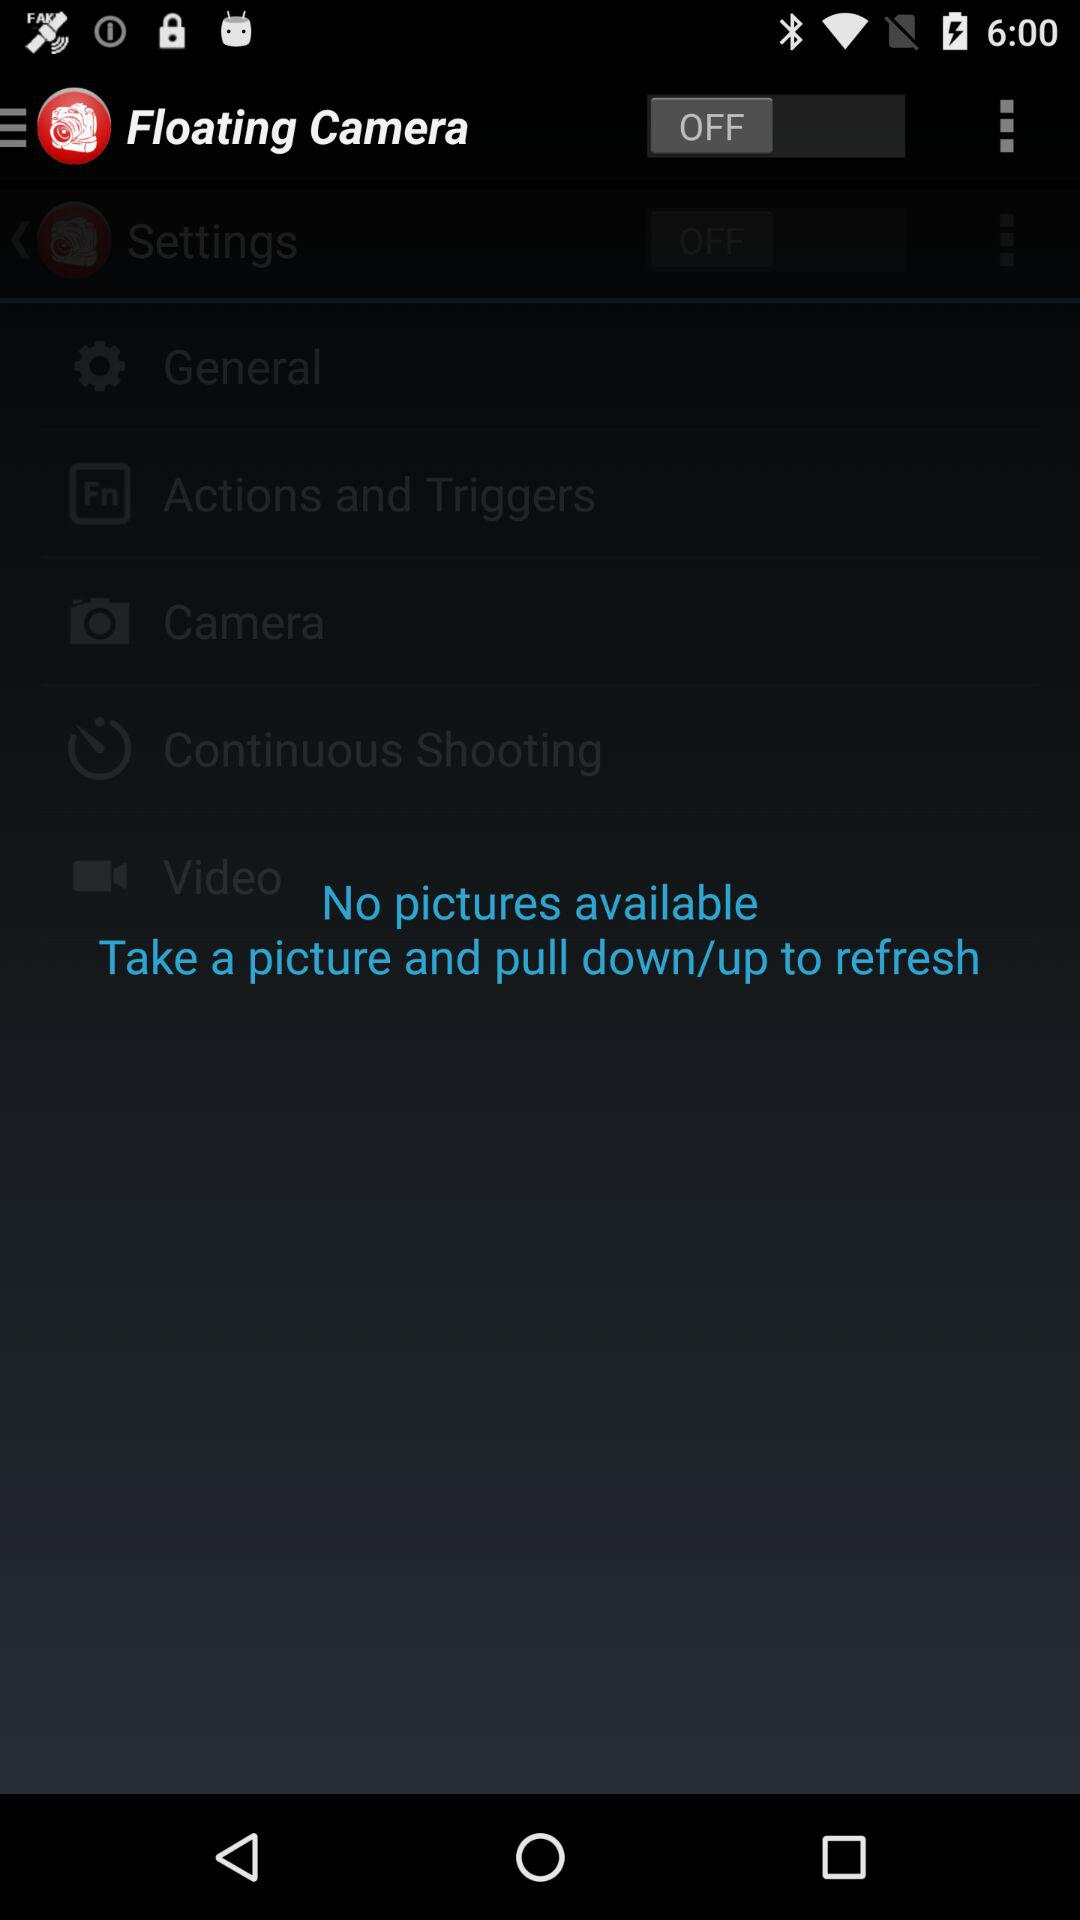What is the status of "Floating Camera"? The status is "off". 